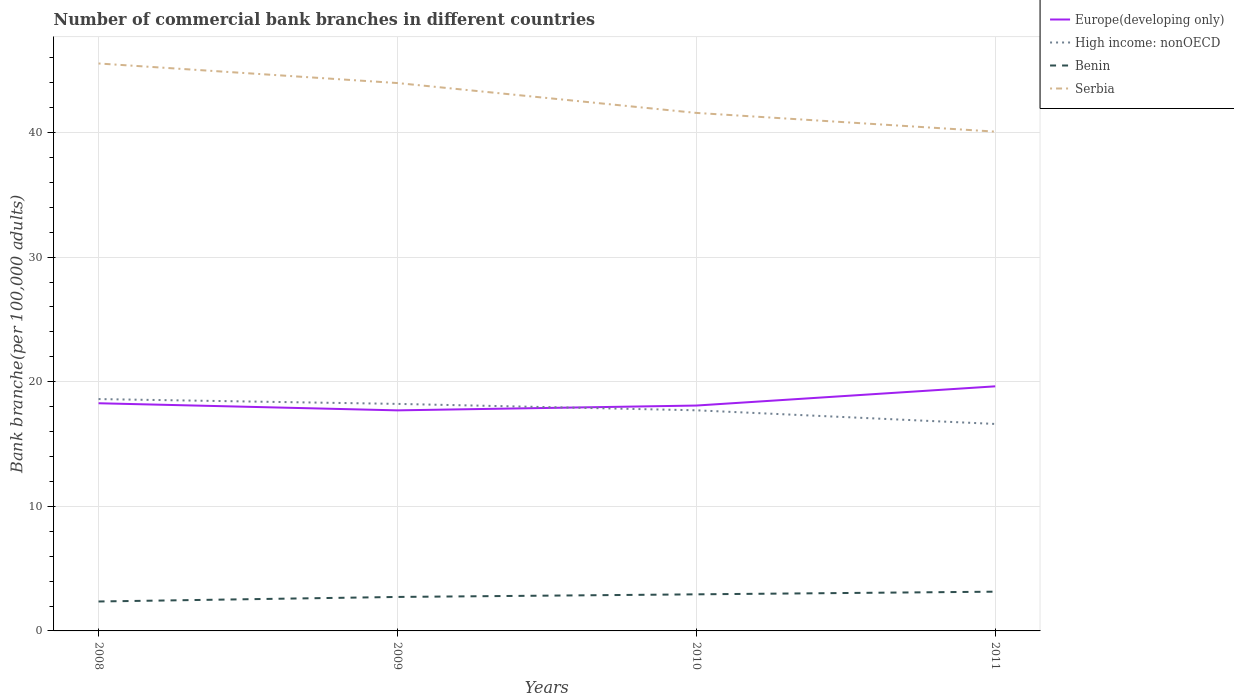How many different coloured lines are there?
Give a very brief answer. 4. Does the line corresponding to Serbia intersect with the line corresponding to Europe(developing only)?
Your answer should be compact. No. Is the number of lines equal to the number of legend labels?
Offer a terse response. Yes. Across all years, what is the maximum number of commercial bank branches in Benin?
Provide a succinct answer. 2.36. In which year was the number of commercial bank branches in Serbia maximum?
Keep it short and to the point. 2011. What is the total number of commercial bank branches in Serbia in the graph?
Ensure brevity in your answer.  3.97. What is the difference between the highest and the second highest number of commercial bank branches in Benin?
Keep it short and to the point. 0.79. What is the difference between the highest and the lowest number of commercial bank branches in Serbia?
Your answer should be compact. 2. How many lines are there?
Offer a terse response. 4. What is the difference between two consecutive major ticks on the Y-axis?
Keep it short and to the point. 10. Does the graph contain grids?
Provide a short and direct response. Yes. Where does the legend appear in the graph?
Your response must be concise. Top right. How are the legend labels stacked?
Provide a succinct answer. Vertical. What is the title of the graph?
Offer a very short reply. Number of commercial bank branches in different countries. Does "East Asia (all income levels)" appear as one of the legend labels in the graph?
Offer a terse response. No. What is the label or title of the X-axis?
Your answer should be compact. Years. What is the label or title of the Y-axis?
Give a very brief answer. Bank branche(per 100,0 adults). What is the Bank branche(per 100,000 adults) in Europe(developing only) in 2008?
Provide a succinct answer. 18.27. What is the Bank branche(per 100,000 adults) of High income: nonOECD in 2008?
Offer a very short reply. 18.61. What is the Bank branche(per 100,000 adults) of Benin in 2008?
Your response must be concise. 2.36. What is the Bank branche(per 100,000 adults) of Serbia in 2008?
Provide a succinct answer. 45.54. What is the Bank branche(per 100,000 adults) in Europe(developing only) in 2009?
Offer a very short reply. 17.7. What is the Bank branche(per 100,000 adults) in High income: nonOECD in 2009?
Provide a short and direct response. 18.22. What is the Bank branche(per 100,000 adults) of Benin in 2009?
Keep it short and to the point. 2.73. What is the Bank branche(per 100,000 adults) of Serbia in 2009?
Provide a succinct answer. 43.97. What is the Bank branche(per 100,000 adults) of Europe(developing only) in 2010?
Provide a short and direct response. 18.09. What is the Bank branche(per 100,000 adults) of High income: nonOECD in 2010?
Your answer should be compact. 17.71. What is the Bank branche(per 100,000 adults) in Benin in 2010?
Your answer should be very brief. 2.94. What is the Bank branche(per 100,000 adults) of Serbia in 2010?
Your response must be concise. 41.57. What is the Bank branche(per 100,000 adults) of Europe(developing only) in 2011?
Provide a short and direct response. 19.63. What is the Bank branche(per 100,000 adults) of High income: nonOECD in 2011?
Your response must be concise. 16.61. What is the Bank branche(per 100,000 adults) in Benin in 2011?
Provide a succinct answer. 3.15. What is the Bank branche(per 100,000 adults) in Serbia in 2011?
Provide a short and direct response. 40.07. Across all years, what is the maximum Bank branche(per 100,000 adults) in Europe(developing only)?
Provide a short and direct response. 19.63. Across all years, what is the maximum Bank branche(per 100,000 adults) in High income: nonOECD?
Offer a terse response. 18.61. Across all years, what is the maximum Bank branche(per 100,000 adults) of Benin?
Your answer should be very brief. 3.15. Across all years, what is the maximum Bank branche(per 100,000 adults) of Serbia?
Offer a very short reply. 45.54. Across all years, what is the minimum Bank branche(per 100,000 adults) in Europe(developing only)?
Provide a succinct answer. 17.7. Across all years, what is the minimum Bank branche(per 100,000 adults) in High income: nonOECD?
Keep it short and to the point. 16.61. Across all years, what is the minimum Bank branche(per 100,000 adults) of Benin?
Offer a very short reply. 2.36. Across all years, what is the minimum Bank branche(per 100,000 adults) of Serbia?
Your answer should be compact. 40.07. What is the total Bank branche(per 100,000 adults) of Europe(developing only) in the graph?
Your response must be concise. 73.69. What is the total Bank branche(per 100,000 adults) in High income: nonOECD in the graph?
Your answer should be very brief. 71.15. What is the total Bank branche(per 100,000 adults) in Benin in the graph?
Provide a succinct answer. 11.18. What is the total Bank branche(per 100,000 adults) of Serbia in the graph?
Ensure brevity in your answer.  171.16. What is the difference between the Bank branche(per 100,000 adults) in Europe(developing only) in 2008 and that in 2009?
Provide a short and direct response. 0.57. What is the difference between the Bank branche(per 100,000 adults) in High income: nonOECD in 2008 and that in 2009?
Make the answer very short. 0.39. What is the difference between the Bank branche(per 100,000 adults) of Benin in 2008 and that in 2009?
Offer a very short reply. -0.36. What is the difference between the Bank branche(per 100,000 adults) of Serbia in 2008 and that in 2009?
Your response must be concise. 1.57. What is the difference between the Bank branche(per 100,000 adults) in Europe(developing only) in 2008 and that in 2010?
Make the answer very short. 0.18. What is the difference between the Bank branche(per 100,000 adults) of High income: nonOECD in 2008 and that in 2010?
Offer a very short reply. 0.9. What is the difference between the Bank branche(per 100,000 adults) in Benin in 2008 and that in 2010?
Offer a very short reply. -0.57. What is the difference between the Bank branche(per 100,000 adults) of Serbia in 2008 and that in 2010?
Ensure brevity in your answer.  3.97. What is the difference between the Bank branche(per 100,000 adults) in Europe(developing only) in 2008 and that in 2011?
Ensure brevity in your answer.  -1.36. What is the difference between the Bank branche(per 100,000 adults) in High income: nonOECD in 2008 and that in 2011?
Offer a terse response. 2. What is the difference between the Bank branche(per 100,000 adults) in Benin in 2008 and that in 2011?
Provide a succinct answer. -0.79. What is the difference between the Bank branche(per 100,000 adults) of Serbia in 2008 and that in 2011?
Provide a succinct answer. 5.47. What is the difference between the Bank branche(per 100,000 adults) of Europe(developing only) in 2009 and that in 2010?
Your response must be concise. -0.39. What is the difference between the Bank branche(per 100,000 adults) of High income: nonOECD in 2009 and that in 2010?
Your answer should be compact. 0.51. What is the difference between the Bank branche(per 100,000 adults) of Benin in 2009 and that in 2010?
Your answer should be compact. -0.21. What is the difference between the Bank branche(per 100,000 adults) of Serbia in 2009 and that in 2010?
Your answer should be compact. 2.4. What is the difference between the Bank branche(per 100,000 adults) of Europe(developing only) in 2009 and that in 2011?
Offer a terse response. -1.93. What is the difference between the Bank branche(per 100,000 adults) of High income: nonOECD in 2009 and that in 2011?
Give a very brief answer. 1.61. What is the difference between the Bank branche(per 100,000 adults) of Benin in 2009 and that in 2011?
Provide a short and direct response. -0.42. What is the difference between the Bank branche(per 100,000 adults) in Serbia in 2009 and that in 2011?
Your response must be concise. 3.9. What is the difference between the Bank branche(per 100,000 adults) of Europe(developing only) in 2010 and that in 2011?
Provide a short and direct response. -1.54. What is the difference between the Bank branche(per 100,000 adults) of High income: nonOECD in 2010 and that in 2011?
Give a very brief answer. 1.1. What is the difference between the Bank branche(per 100,000 adults) in Benin in 2010 and that in 2011?
Provide a short and direct response. -0.21. What is the difference between the Bank branche(per 100,000 adults) of Serbia in 2010 and that in 2011?
Provide a succinct answer. 1.5. What is the difference between the Bank branche(per 100,000 adults) of Europe(developing only) in 2008 and the Bank branche(per 100,000 adults) of High income: nonOECD in 2009?
Your answer should be very brief. 0.05. What is the difference between the Bank branche(per 100,000 adults) of Europe(developing only) in 2008 and the Bank branche(per 100,000 adults) of Benin in 2009?
Make the answer very short. 15.55. What is the difference between the Bank branche(per 100,000 adults) in Europe(developing only) in 2008 and the Bank branche(per 100,000 adults) in Serbia in 2009?
Your answer should be compact. -25.7. What is the difference between the Bank branche(per 100,000 adults) of High income: nonOECD in 2008 and the Bank branche(per 100,000 adults) of Benin in 2009?
Your answer should be very brief. 15.88. What is the difference between the Bank branche(per 100,000 adults) in High income: nonOECD in 2008 and the Bank branche(per 100,000 adults) in Serbia in 2009?
Offer a terse response. -25.36. What is the difference between the Bank branche(per 100,000 adults) of Benin in 2008 and the Bank branche(per 100,000 adults) of Serbia in 2009?
Your answer should be very brief. -41.61. What is the difference between the Bank branche(per 100,000 adults) in Europe(developing only) in 2008 and the Bank branche(per 100,000 adults) in High income: nonOECD in 2010?
Your response must be concise. 0.57. What is the difference between the Bank branche(per 100,000 adults) of Europe(developing only) in 2008 and the Bank branche(per 100,000 adults) of Benin in 2010?
Give a very brief answer. 15.34. What is the difference between the Bank branche(per 100,000 adults) of Europe(developing only) in 2008 and the Bank branche(per 100,000 adults) of Serbia in 2010?
Your answer should be very brief. -23.3. What is the difference between the Bank branche(per 100,000 adults) in High income: nonOECD in 2008 and the Bank branche(per 100,000 adults) in Benin in 2010?
Provide a short and direct response. 15.67. What is the difference between the Bank branche(per 100,000 adults) in High income: nonOECD in 2008 and the Bank branche(per 100,000 adults) in Serbia in 2010?
Keep it short and to the point. -22.97. What is the difference between the Bank branche(per 100,000 adults) of Benin in 2008 and the Bank branche(per 100,000 adults) of Serbia in 2010?
Provide a succinct answer. -39.21. What is the difference between the Bank branche(per 100,000 adults) of Europe(developing only) in 2008 and the Bank branche(per 100,000 adults) of High income: nonOECD in 2011?
Ensure brevity in your answer.  1.66. What is the difference between the Bank branche(per 100,000 adults) in Europe(developing only) in 2008 and the Bank branche(per 100,000 adults) in Benin in 2011?
Give a very brief answer. 15.12. What is the difference between the Bank branche(per 100,000 adults) in Europe(developing only) in 2008 and the Bank branche(per 100,000 adults) in Serbia in 2011?
Your answer should be compact. -21.8. What is the difference between the Bank branche(per 100,000 adults) of High income: nonOECD in 2008 and the Bank branche(per 100,000 adults) of Benin in 2011?
Offer a very short reply. 15.46. What is the difference between the Bank branche(per 100,000 adults) of High income: nonOECD in 2008 and the Bank branche(per 100,000 adults) of Serbia in 2011?
Provide a succinct answer. -21.46. What is the difference between the Bank branche(per 100,000 adults) of Benin in 2008 and the Bank branche(per 100,000 adults) of Serbia in 2011?
Make the answer very short. -37.71. What is the difference between the Bank branche(per 100,000 adults) of Europe(developing only) in 2009 and the Bank branche(per 100,000 adults) of High income: nonOECD in 2010?
Offer a very short reply. -0. What is the difference between the Bank branche(per 100,000 adults) of Europe(developing only) in 2009 and the Bank branche(per 100,000 adults) of Benin in 2010?
Give a very brief answer. 14.77. What is the difference between the Bank branche(per 100,000 adults) in Europe(developing only) in 2009 and the Bank branche(per 100,000 adults) in Serbia in 2010?
Keep it short and to the point. -23.87. What is the difference between the Bank branche(per 100,000 adults) of High income: nonOECD in 2009 and the Bank branche(per 100,000 adults) of Benin in 2010?
Provide a short and direct response. 15.28. What is the difference between the Bank branche(per 100,000 adults) in High income: nonOECD in 2009 and the Bank branche(per 100,000 adults) in Serbia in 2010?
Provide a short and direct response. -23.35. What is the difference between the Bank branche(per 100,000 adults) of Benin in 2009 and the Bank branche(per 100,000 adults) of Serbia in 2010?
Offer a very short reply. -38.85. What is the difference between the Bank branche(per 100,000 adults) of Europe(developing only) in 2009 and the Bank branche(per 100,000 adults) of High income: nonOECD in 2011?
Provide a short and direct response. 1.09. What is the difference between the Bank branche(per 100,000 adults) in Europe(developing only) in 2009 and the Bank branche(per 100,000 adults) in Benin in 2011?
Make the answer very short. 14.55. What is the difference between the Bank branche(per 100,000 adults) in Europe(developing only) in 2009 and the Bank branche(per 100,000 adults) in Serbia in 2011?
Your response must be concise. -22.37. What is the difference between the Bank branche(per 100,000 adults) of High income: nonOECD in 2009 and the Bank branche(per 100,000 adults) of Benin in 2011?
Keep it short and to the point. 15.07. What is the difference between the Bank branche(per 100,000 adults) of High income: nonOECD in 2009 and the Bank branche(per 100,000 adults) of Serbia in 2011?
Make the answer very short. -21.85. What is the difference between the Bank branche(per 100,000 adults) of Benin in 2009 and the Bank branche(per 100,000 adults) of Serbia in 2011?
Provide a short and direct response. -37.35. What is the difference between the Bank branche(per 100,000 adults) in Europe(developing only) in 2010 and the Bank branche(per 100,000 adults) in High income: nonOECD in 2011?
Offer a terse response. 1.48. What is the difference between the Bank branche(per 100,000 adults) of Europe(developing only) in 2010 and the Bank branche(per 100,000 adults) of Benin in 2011?
Your response must be concise. 14.94. What is the difference between the Bank branche(per 100,000 adults) of Europe(developing only) in 2010 and the Bank branche(per 100,000 adults) of Serbia in 2011?
Make the answer very short. -21.98. What is the difference between the Bank branche(per 100,000 adults) in High income: nonOECD in 2010 and the Bank branche(per 100,000 adults) in Benin in 2011?
Offer a very short reply. 14.56. What is the difference between the Bank branche(per 100,000 adults) in High income: nonOECD in 2010 and the Bank branche(per 100,000 adults) in Serbia in 2011?
Keep it short and to the point. -22.37. What is the difference between the Bank branche(per 100,000 adults) in Benin in 2010 and the Bank branche(per 100,000 adults) in Serbia in 2011?
Ensure brevity in your answer.  -37.14. What is the average Bank branche(per 100,000 adults) of Europe(developing only) per year?
Make the answer very short. 18.42. What is the average Bank branche(per 100,000 adults) in High income: nonOECD per year?
Your response must be concise. 17.79. What is the average Bank branche(per 100,000 adults) in Benin per year?
Give a very brief answer. 2.79. What is the average Bank branche(per 100,000 adults) of Serbia per year?
Offer a terse response. 42.79. In the year 2008, what is the difference between the Bank branche(per 100,000 adults) of Europe(developing only) and Bank branche(per 100,000 adults) of High income: nonOECD?
Provide a succinct answer. -0.34. In the year 2008, what is the difference between the Bank branche(per 100,000 adults) in Europe(developing only) and Bank branche(per 100,000 adults) in Benin?
Ensure brevity in your answer.  15.91. In the year 2008, what is the difference between the Bank branche(per 100,000 adults) in Europe(developing only) and Bank branche(per 100,000 adults) in Serbia?
Offer a very short reply. -27.27. In the year 2008, what is the difference between the Bank branche(per 100,000 adults) of High income: nonOECD and Bank branche(per 100,000 adults) of Benin?
Your answer should be compact. 16.25. In the year 2008, what is the difference between the Bank branche(per 100,000 adults) of High income: nonOECD and Bank branche(per 100,000 adults) of Serbia?
Provide a succinct answer. -26.93. In the year 2008, what is the difference between the Bank branche(per 100,000 adults) of Benin and Bank branche(per 100,000 adults) of Serbia?
Ensure brevity in your answer.  -43.18. In the year 2009, what is the difference between the Bank branche(per 100,000 adults) of Europe(developing only) and Bank branche(per 100,000 adults) of High income: nonOECD?
Provide a succinct answer. -0.52. In the year 2009, what is the difference between the Bank branche(per 100,000 adults) in Europe(developing only) and Bank branche(per 100,000 adults) in Benin?
Offer a terse response. 14.98. In the year 2009, what is the difference between the Bank branche(per 100,000 adults) in Europe(developing only) and Bank branche(per 100,000 adults) in Serbia?
Keep it short and to the point. -26.27. In the year 2009, what is the difference between the Bank branche(per 100,000 adults) of High income: nonOECD and Bank branche(per 100,000 adults) of Benin?
Your response must be concise. 15.49. In the year 2009, what is the difference between the Bank branche(per 100,000 adults) in High income: nonOECD and Bank branche(per 100,000 adults) in Serbia?
Provide a short and direct response. -25.75. In the year 2009, what is the difference between the Bank branche(per 100,000 adults) in Benin and Bank branche(per 100,000 adults) in Serbia?
Your answer should be compact. -41.24. In the year 2010, what is the difference between the Bank branche(per 100,000 adults) of Europe(developing only) and Bank branche(per 100,000 adults) of High income: nonOECD?
Offer a very short reply. 0.38. In the year 2010, what is the difference between the Bank branche(per 100,000 adults) in Europe(developing only) and Bank branche(per 100,000 adults) in Benin?
Your response must be concise. 15.15. In the year 2010, what is the difference between the Bank branche(per 100,000 adults) in Europe(developing only) and Bank branche(per 100,000 adults) in Serbia?
Give a very brief answer. -23.49. In the year 2010, what is the difference between the Bank branche(per 100,000 adults) in High income: nonOECD and Bank branche(per 100,000 adults) in Benin?
Your response must be concise. 14.77. In the year 2010, what is the difference between the Bank branche(per 100,000 adults) of High income: nonOECD and Bank branche(per 100,000 adults) of Serbia?
Your response must be concise. -23.87. In the year 2010, what is the difference between the Bank branche(per 100,000 adults) in Benin and Bank branche(per 100,000 adults) in Serbia?
Make the answer very short. -38.64. In the year 2011, what is the difference between the Bank branche(per 100,000 adults) in Europe(developing only) and Bank branche(per 100,000 adults) in High income: nonOECD?
Provide a short and direct response. 3.02. In the year 2011, what is the difference between the Bank branche(per 100,000 adults) in Europe(developing only) and Bank branche(per 100,000 adults) in Benin?
Give a very brief answer. 16.48. In the year 2011, what is the difference between the Bank branche(per 100,000 adults) of Europe(developing only) and Bank branche(per 100,000 adults) of Serbia?
Offer a very short reply. -20.44. In the year 2011, what is the difference between the Bank branche(per 100,000 adults) of High income: nonOECD and Bank branche(per 100,000 adults) of Benin?
Make the answer very short. 13.46. In the year 2011, what is the difference between the Bank branche(per 100,000 adults) in High income: nonOECD and Bank branche(per 100,000 adults) in Serbia?
Offer a very short reply. -23.46. In the year 2011, what is the difference between the Bank branche(per 100,000 adults) of Benin and Bank branche(per 100,000 adults) of Serbia?
Your response must be concise. -36.92. What is the ratio of the Bank branche(per 100,000 adults) in Europe(developing only) in 2008 to that in 2009?
Offer a terse response. 1.03. What is the ratio of the Bank branche(per 100,000 adults) of High income: nonOECD in 2008 to that in 2009?
Your response must be concise. 1.02. What is the ratio of the Bank branche(per 100,000 adults) in Benin in 2008 to that in 2009?
Make the answer very short. 0.87. What is the ratio of the Bank branche(per 100,000 adults) in Serbia in 2008 to that in 2009?
Provide a short and direct response. 1.04. What is the ratio of the Bank branche(per 100,000 adults) of Europe(developing only) in 2008 to that in 2010?
Ensure brevity in your answer.  1.01. What is the ratio of the Bank branche(per 100,000 adults) of High income: nonOECD in 2008 to that in 2010?
Ensure brevity in your answer.  1.05. What is the ratio of the Bank branche(per 100,000 adults) of Benin in 2008 to that in 2010?
Ensure brevity in your answer.  0.8. What is the ratio of the Bank branche(per 100,000 adults) in Serbia in 2008 to that in 2010?
Provide a succinct answer. 1.1. What is the ratio of the Bank branche(per 100,000 adults) of Europe(developing only) in 2008 to that in 2011?
Keep it short and to the point. 0.93. What is the ratio of the Bank branche(per 100,000 adults) in High income: nonOECD in 2008 to that in 2011?
Keep it short and to the point. 1.12. What is the ratio of the Bank branche(per 100,000 adults) in Benin in 2008 to that in 2011?
Ensure brevity in your answer.  0.75. What is the ratio of the Bank branche(per 100,000 adults) in Serbia in 2008 to that in 2011?
Make the answer very short. 1.14. What is the ratio of the Bank branche(per 100,000 adults) in Europe(developing only) in 2009 to that in 2010?
Make the answer very short. 0.98. What is the ratio of the Bank branche(per 100,000 adults) in High income: nonOECD in 2009 to that in 2010?
Offer a terse response. 1.03. What is the ratio of the Bank branche(per 100,000 adults) of Benin in 2009 to that in 2010?
Provide a short and direct response. 0.93. What is the ratio of the Bank branche(per 100,000 adults) of Serbia in 2009 to that in 2010?
Offer a very short reply. 1.06. What is the ratio of the Bank branche(per 100,000 adults) in Europe(developing only) in 2009 to that in 2011?
Offer a terse response. 0.9. What is the ratio of the Bank branche(per 100,000 adults) in High income: nonOECD in 2009 to that in 2011?
Your answer should be compact. 1.1. What is the ratio of the Bank branche(per 100,000 adults) in Benin in 2009 to that in 2011?
Your answer should be compact. 0.87. What is the ratio of the Bank branche(per 100,000 adults) of Serbia in 2009 to that in 2011?
Offer a very short reply. 1.1. What is the ratio of the Bank branche(per 100,000 adults) of Europe(developing only) in 2010 to that in 2011?
Ensure brevity in your answer.  0.92. What is the ratio of the Bank branche(per 100,000 adults) of High income: nonOECD in 2010 to that in 2011?
Offer a terse response. 1.07. What is the ratio of the Bank branche(per 100,000 adults) of Benin in 2010 to that in 2011?
Make the answer very short. 0.93. What is the ratio of the Bank branche(per 100,000 adults) in Serbia in 2010 to that in 2011?
Your answer should be very brief. 1.04. What is the difference between the highest and the second highest Bank branche(per 100,000 adults) of Europe(developing only)?
Ensure brevity in your answer.  1.36. What is the difference between the highest and the second highest Bank branche(per 100,000 adults) in High income: nonOECD?
Your answer should be very brief. 0.39. What is the difference between the highest and the second highest Bank branche(per 100,000 adults) of Benin?
Ensure brevity in your answer.  0.21. What is the difference between the highest and the second highest Bank branche(per 100,000 adults) in Serbia?
Offer a terse response. 1.57. What is the difference between the highest and the lowest Bank branche(per 100,000 adults) in Europe(developing only)?
Your answer should be very brief. 1.93. What is the difference between the highest and the lowest Bank branche(per 100,000 adults) in High income: nonOECD?
Keep it short and to the point. 2. What is the difference between the highest and the lowest Bank branche(per 100,000 adults) in Benin?
Offer a very short reply. 0.79. What is the difference between the highest and the lowest Bank branche(per 100,000 adults) in Serbia?
Give a very brief answer. 5.47. 